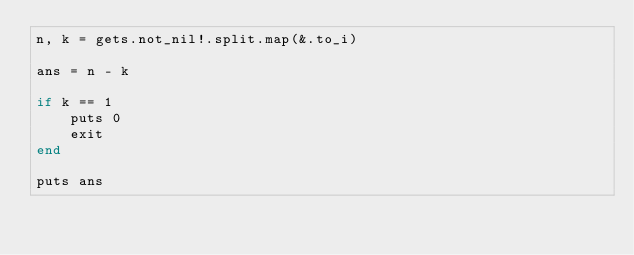<code> <loc_0><loc_0><loc_500><loc_500><_Crystal_>n, k = gets.not_nil!.split.map(&.to_i)

ans = n - k

if k == 1
    puts 0
    exit
end

puts ans</code> 